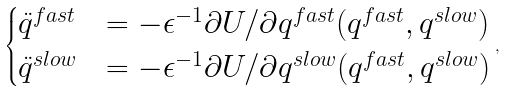<formula> <loc_0><loc_0><loc_500><loc_500>\begin{cases} \ddot { q } ^ { f a s t } & = - \epsilon ^ { - 1 } \partial U / \partial q ^ { f a s t } ( q ^ { f a s t } , q ^ { s l o w } ) \\ \ddot { q } ^ { s l o w } & = - \epsilon ^ { - 1 } \partial U / \partial q ^ { s l o w } ( q ^ { f a s t } , q ^ { s l o w } ) \end{cases} ,</formula> 